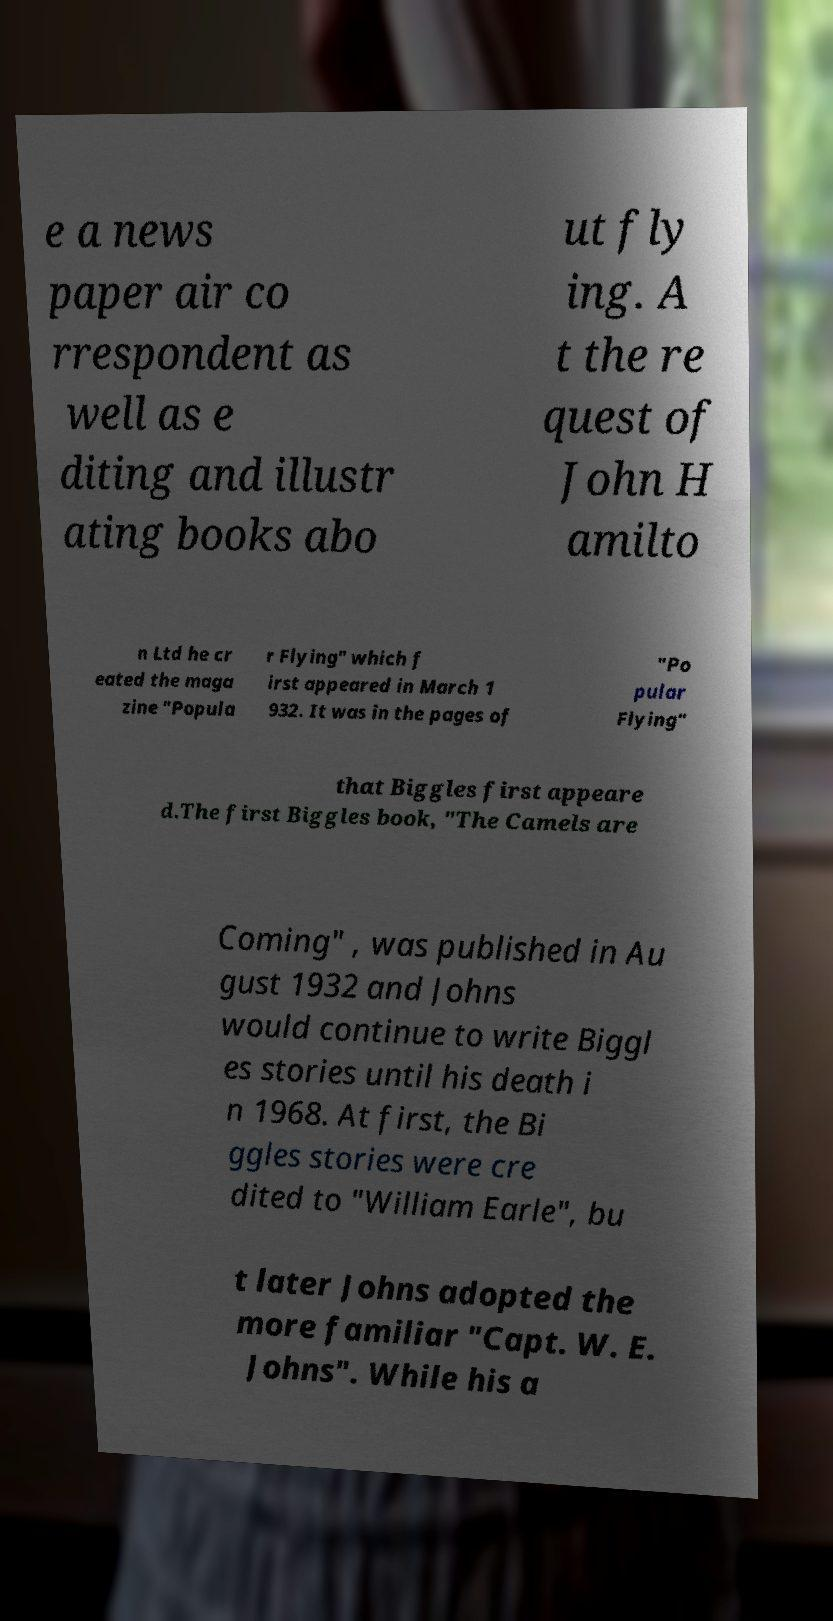Could you assist in decoding the text presented in this image and type it out clearly? e a news paper air co rrespondent as well as e diting and illustr ating books abo ut fly ing. A t the re quest of John H amilto n Ltd he cr eated the maga zine "Popula r Flying" which f irst appeared in March 1 932. It was in the pages of "Po pular Flying" that Biggles first appeare d.The first Biggles book, "The Camels are Coming" , was published in Au gust 1932 and Johns would continue to write Biggl es stories until his death i n 1968. At first, the Bi ggles stories were cre dited to "William Earle", bu t later Johns adopted the more familiar "Capt. W. E. Johns". While his a 